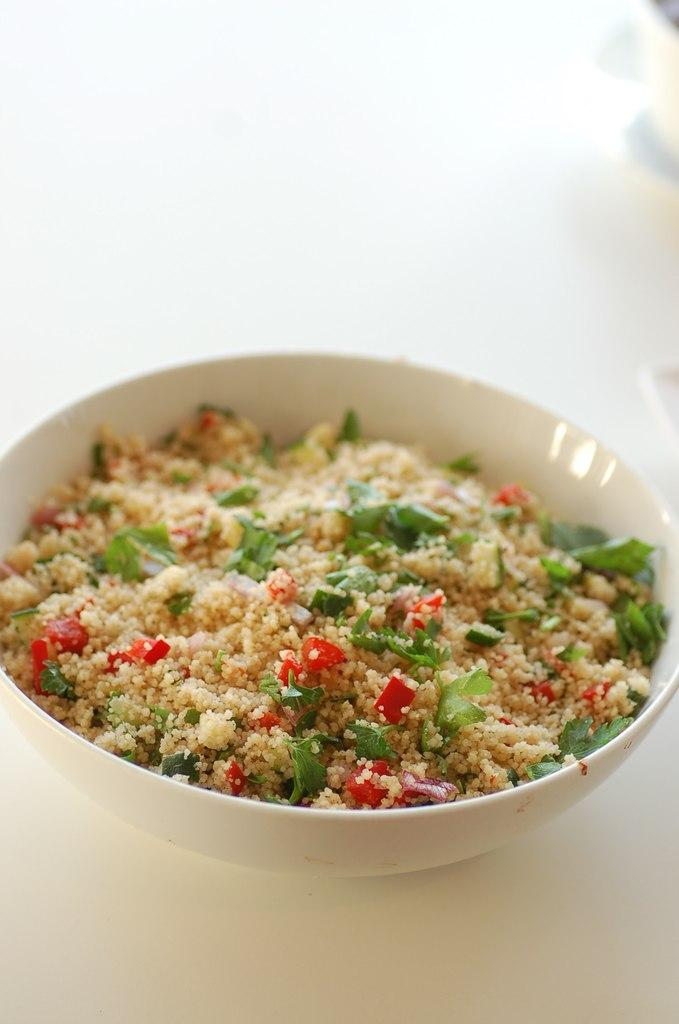What is the color of the surface in the image? The surface in the image is white. What object is placed on the white surface? There is a white bowl on the surface. What can be found inside the white bowl? The bowl contains a food item that has cream, green, and red colors. Are there any cribs visible in the image? No, there are no cribs present in the image. What type of bears can be seen interacting with the food item in the image? There are no bears present in the image; it only features a white surface, a white bowl, and a food item with cream, green, and red colors. 